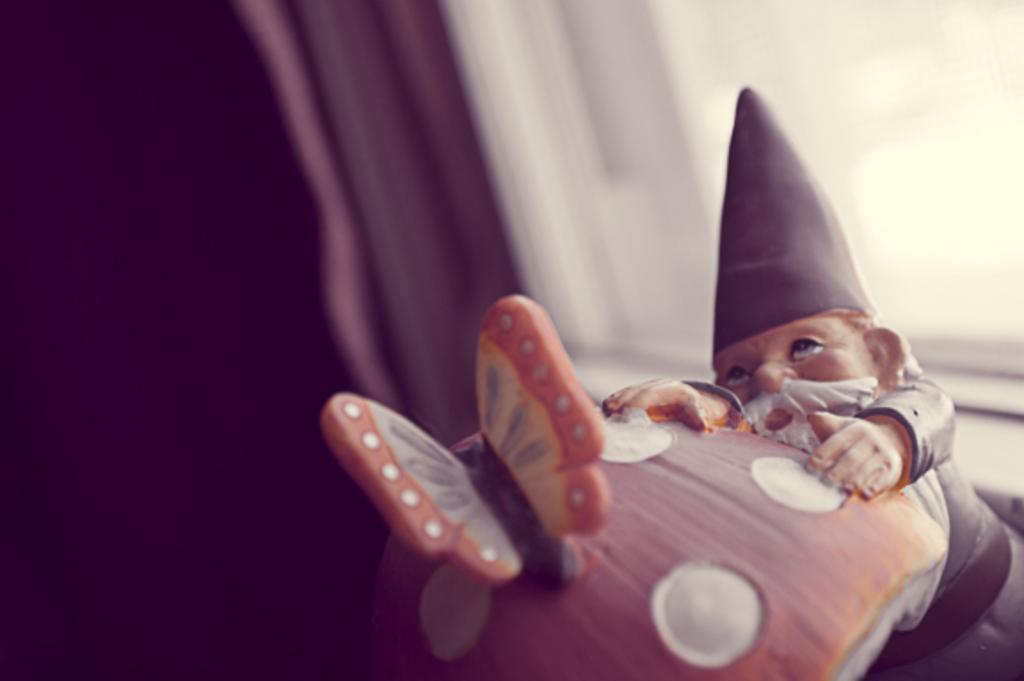Can you describe this image briefly? In this image I can see a toy which is in cream and gray color, in front I can see a pillow in orange and cream color. Background I can see a window and the curtain is in maroon color. 